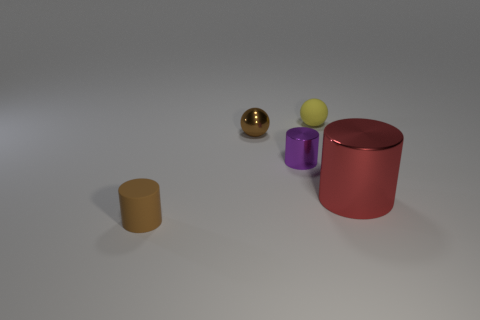Subtract all large red metal cylinders. How many cylinders are left? 2 Subtract 1 cylinders. How many cylinders are left? 2 Add 5 small brown cubes. How many objects exist? 10 Subtract all gray cylinders. Subtract all cyan balls. How many cylinders are left? 3 Add 3 cylinders. How many cylinders are left? 6 Add 1 red rubber things. How many red rubber things exist? 1 Subtract 0 gray balls. How many objects are left? 5 Subtract all balls. How many objects are left? 3 Subtract all yellow rubber spheres. Subtract all small brown objects. How many objects are left? 2 